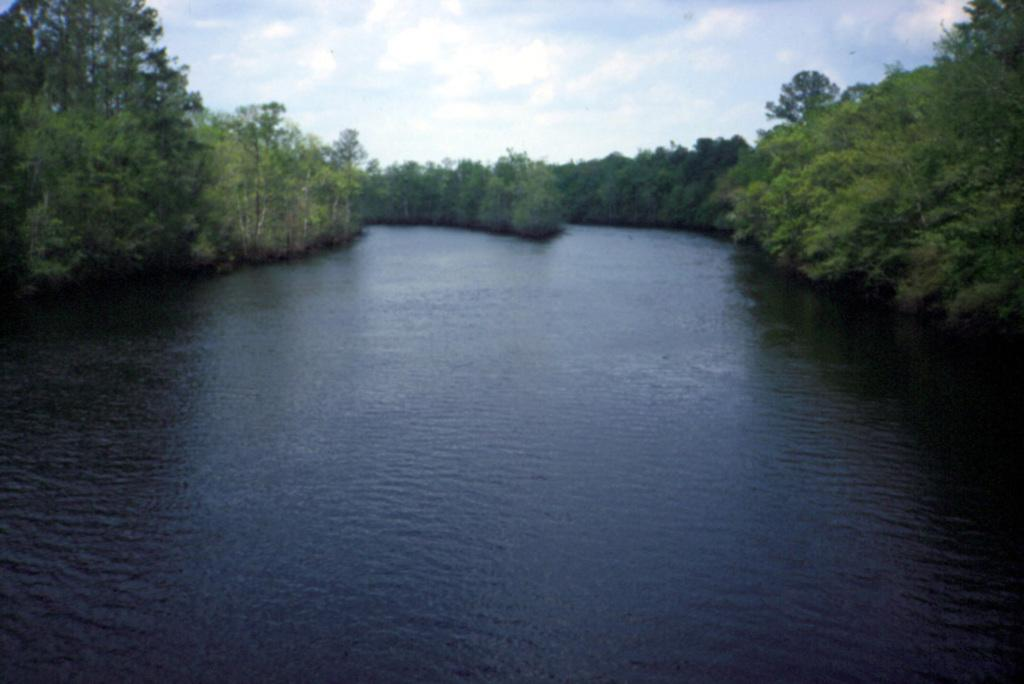What is the main element in the image? There is water in the image. What type of environment surrounds the water? The water is surrounded by plants and trees. What can be seen in the background of the image? There is a sky visible in the background of the image, and clouds are present in the sky. What type of bean is growing near the water in the image? There is no bean present in the image; it features water surrounded by plants and trees. Can you hear the bells ringing in the image? There are no bells present in the image, so it is not possible to hear them ringing. 